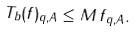Convert formula to latex. <formula><loc_0><loc_0><loc_500><loc_500>\| T _ { b } ( f ) \| _ { q , A } \leq M \, \| f \| _ { q , A } .</formula> 